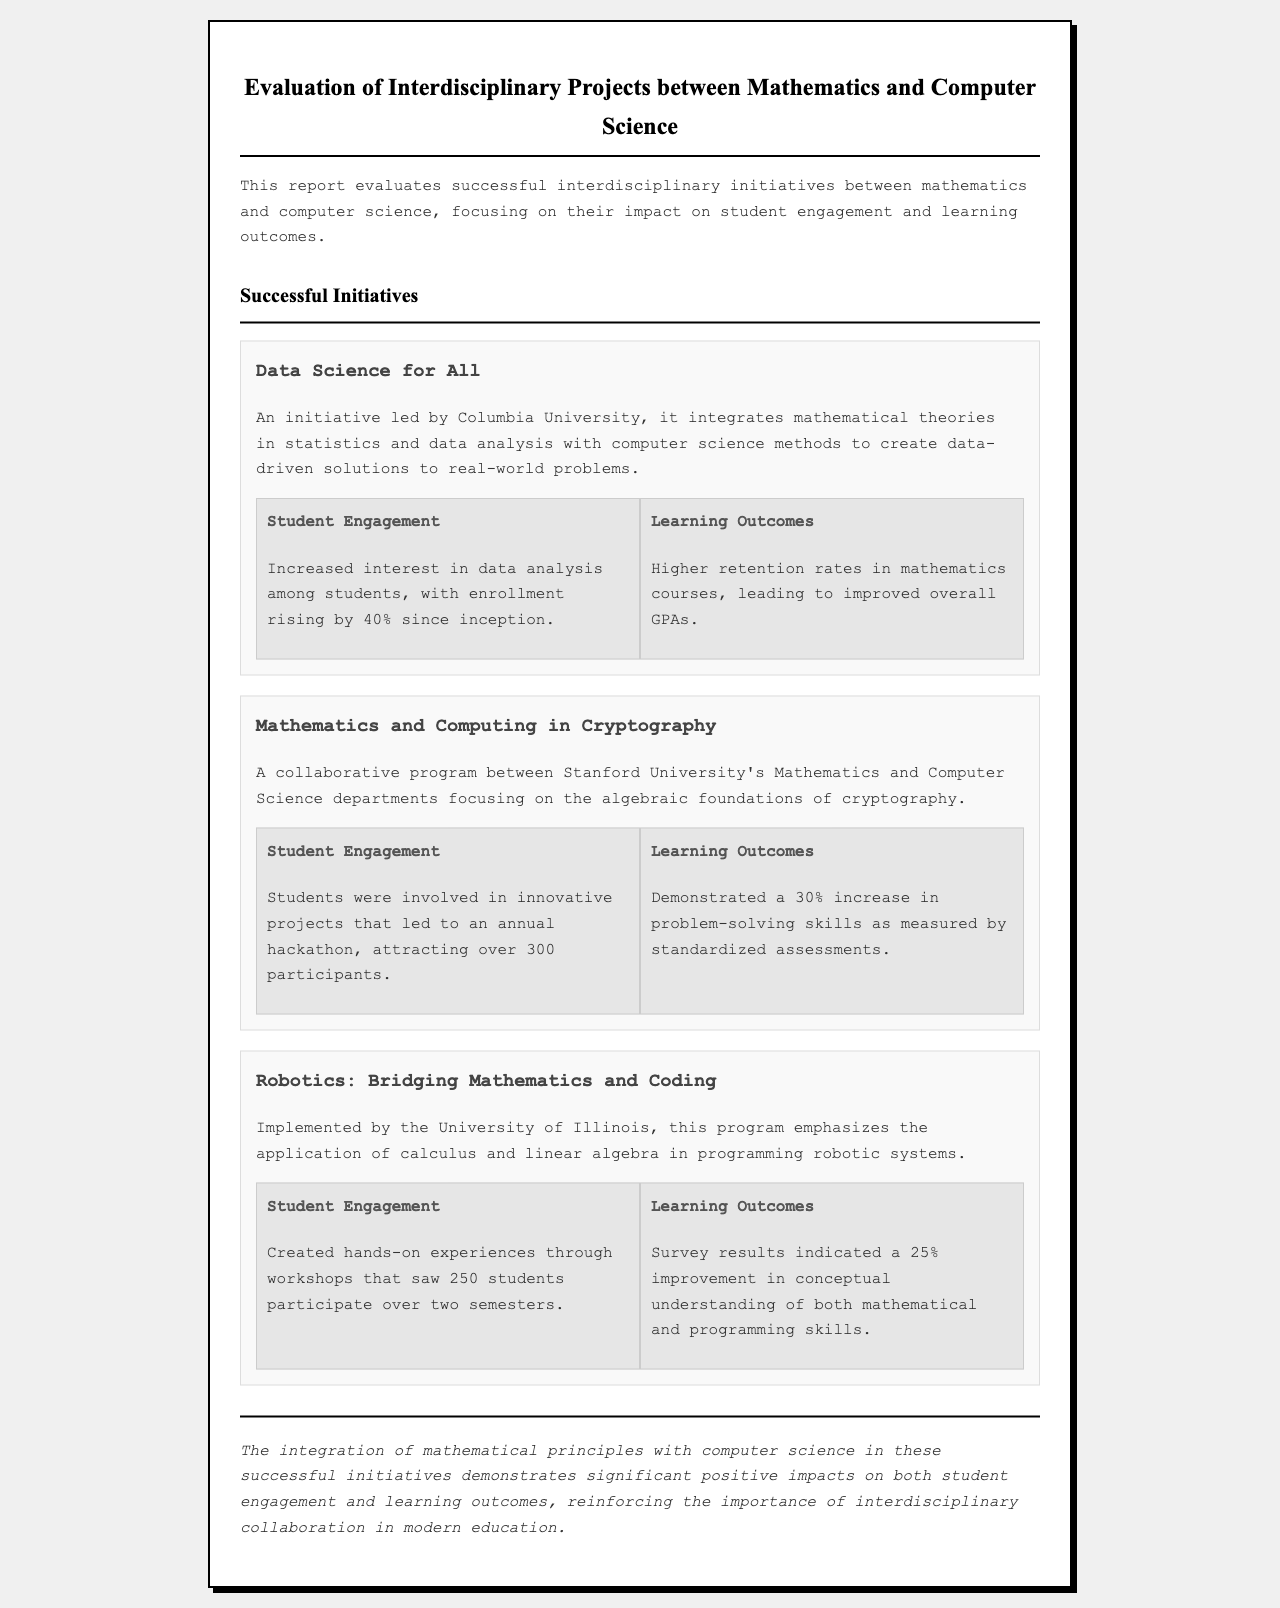what initiative is led by Columbia University? The document specifies that "Data Science for All" is led by Columbia University.
Answer: Data Science for All what was the increase in enrollment for the "Data Science for All" initiative? According to the document, enrollment in the program rose by 40%.
Answer: 40% how many participants were attracted to the annual hackathon in the cryptography program? The document states that over 300 participants were attracted to the annual hackathon.
Answer: over 300 what percentage improvement in problem-solving skills was demonstrated in the cryptography program? The initiative showcases a 30% increase in problem-solving skills as per standardized assessments.
Answer: 30% how many students participated in the Robotics program workshops? The document indicates that 250 students participated in the workshops over two semesters.
Answer: 250 what is the primary focus of the "Robotics: Bridging Mathematics and Coding" program? The focus of the program is the application of calculus and linear algebra in programming robotic systems.
Answer: calculus and linear algebra which departments collaborated for the "Mathematics and Computing in Cryptography" initiative? The document mentions a collaboration between Stanford University's Mathematics and Computer Science departments.
Answer: Stanford University's Mathematics and Computer Science what aspect of student outcomes improved as a result of the interdisciplinary initiatives? The report highlights improvements in both student engagement and learning outcomes as significant impacts.
Answer: student engagement and learning outcomes 